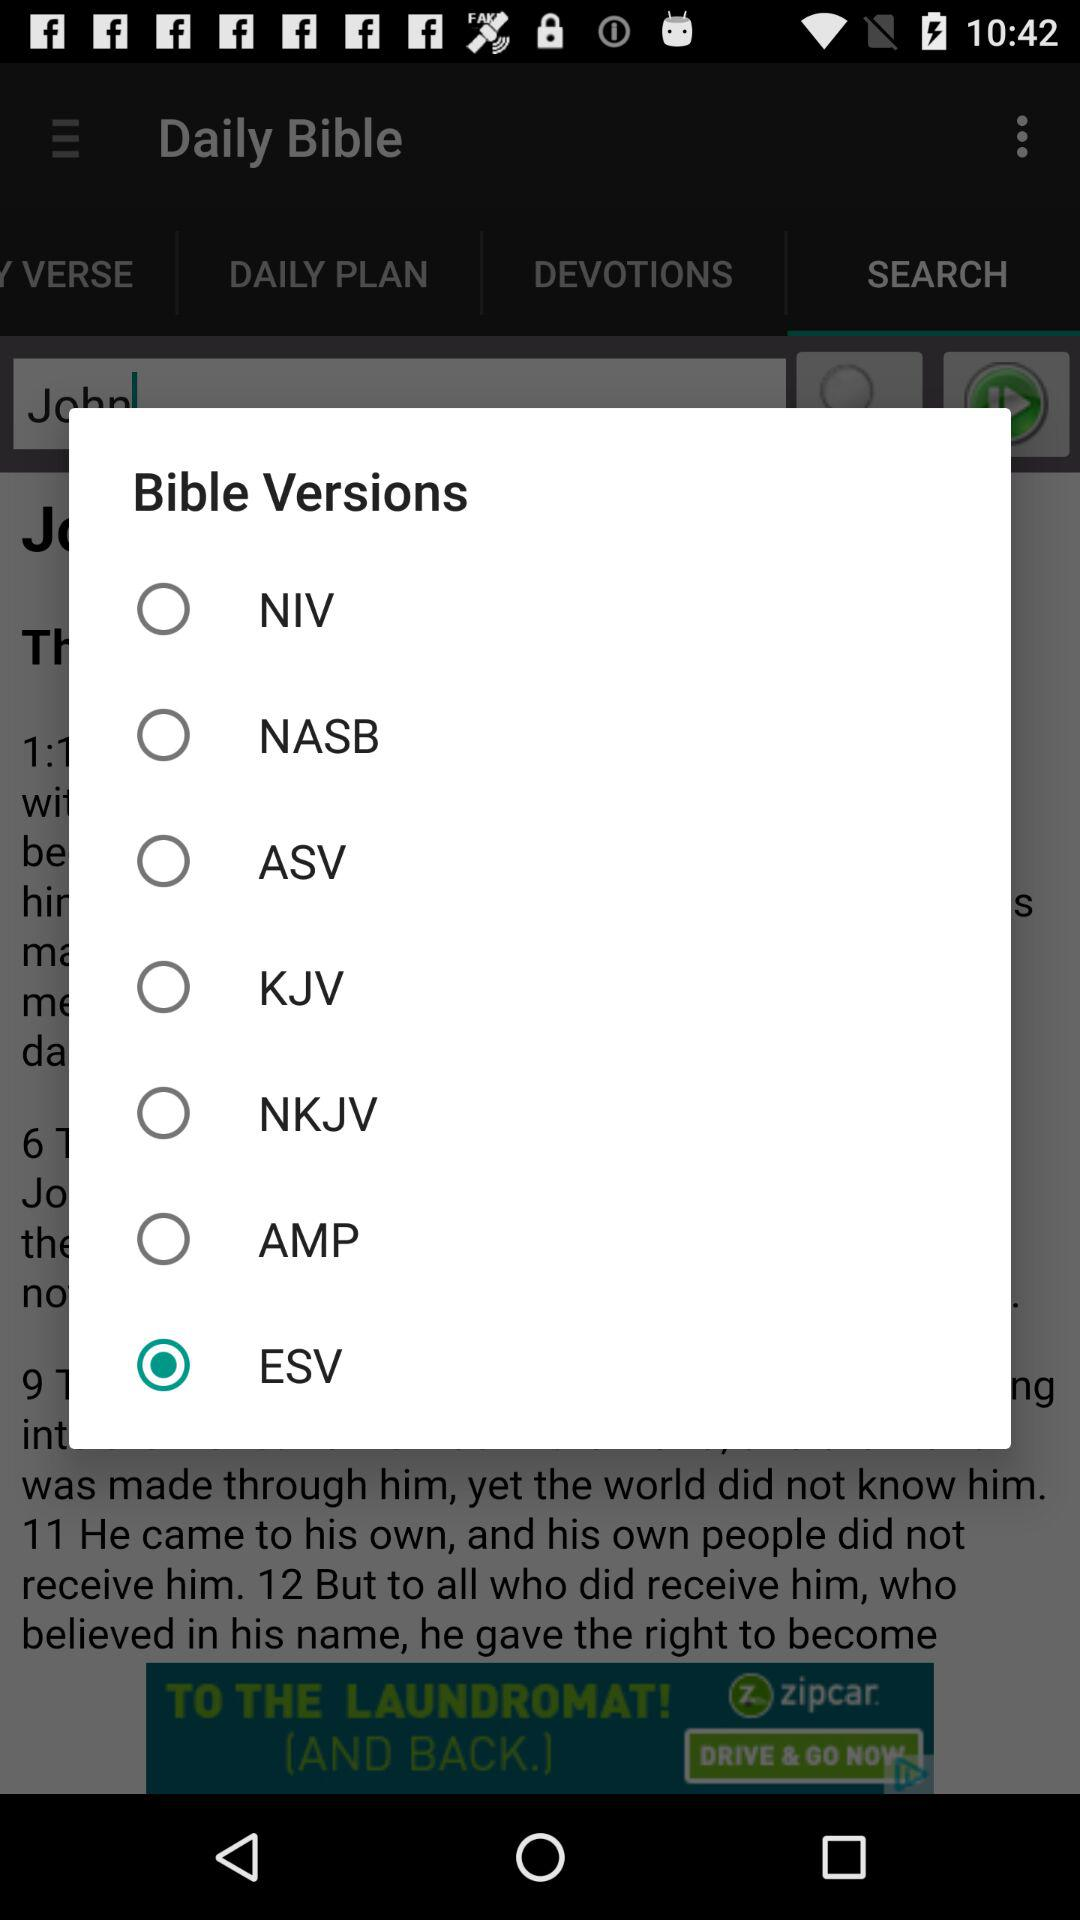How many pages are in the selected version?
When the provided information is insufficient, respond with <no answer>. <no answer> 